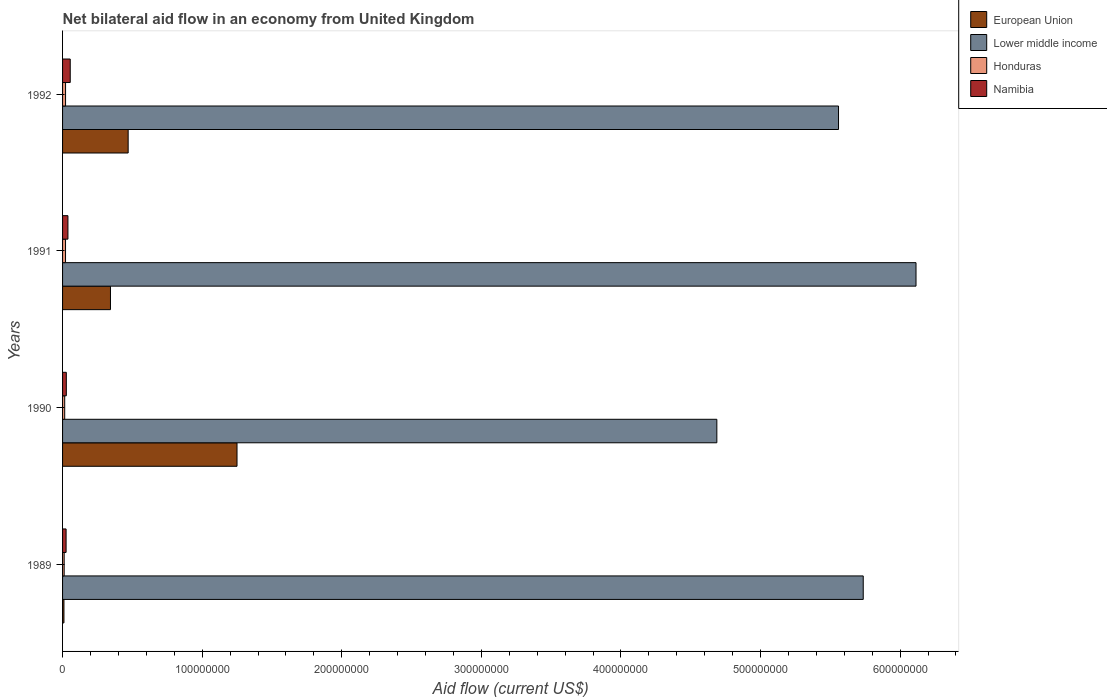How many different coloured bars are there?
Provide a succinct answer. 4. Are the number of bars per tick equal to the number of legend labels?
Ensure brevity in your answer.  Yes. How many bars are there on the 3rd tick from the top?
Ensure brevity in your answer.  4. How many bars are there on the 2nd tick from the bottom?
Provide a short and direct response. 4. What is the label of the 1st group of bars from the top?
Your answer should be compact. 1992. In how many cases, is the number of bars for a given year not equal to the number of legend labels?
Provide a short and direct response. 0. What is the net bilateral aid flow in European Union in 1991?
Your response must be concise. 3.43e+07. Across all years, what is the maximum net bilateral aid flow in Namibia?
Your response must be concise. 5.49e+06. Across all years, what is the minimum net bilateral aid flow in European Union?
Your response must be concise. 9.90e+05. What is the total net bilateral aid flow in Lower middle income in the graph?
Your answer should be compact. 2.21e+09. What is the difference between the net bilateral aid flow in Honduras in 1990 and that in 1991?
Ensure brevity in your answer.  -5.90e+05. What is the difference between the net bilateral aid flow in Namibia in 1990 and the net bilateral aid flow in European Union in 1989?
Keep it short and to the point. 1.71e+06. What is the average net bilateral aid flow in Honduras per year?
Your answer should be compact. 1.74e+06. In the year 1991, what is the difference between the net bilateral aid flow in Namibia and net bilateral aid flow in Honduras?
Offer a very short reply. 1.73e+06. What is the ratio of the net bilateral aid flow in Namibia in 1990 to that in 1992?
Your answer should be very brief. 0.49. Is the net bilateral aid flow in Honduras in 1990 less than that in 1992?
Provide a short and direct response. Yes. What is the difference between the highest and the second highest net bilateral aid flow in Namibia?
Keep it short and to the point. 1.64e+06. What is the difference between the highest and the lowest net bilateral aid flow in European Union?
Give a very brief answer. 1.24e+08. In how many years, is the net bilateral aid flow in Honduras greater than the average net bilateral aid flow in Honduras taken over all years?
Make the answer very short. 2. Is it the case that in every year, the sum of the net bilateral aid flow in European Union and net bilateral aid flow in Honduras is greater than the sum of net bilateral aid flow in Namibia and net bilateral aid flow in Lower middle income?
Your answer should be very brief. No. What does the 4th bar from the bottom in 1990 represents?
Your answer should be compact. Namibia. Are all the bars in the graph horizontal?
Keep it short and to the point. Yes. What is the difference between two consecutive major ticks on the X-axis?
Your response must be concise. 1.00e+08. Are the values on the major ticks of X-axis written in scientific E-notation?
Offer a very short reply. No. Does the graph contain any zero values?
Give a very brief answer. No. Does the graph contain grids?
Provide a succinct answer. No. Where does the legend appear in the graph?
Your answer should be compact. Top right. How many legend labels are there?
Provide a succinct answer. 4. What is the title of the graph?
Offer a terse response. Net bilateral aid flow in an economy from United Kingdom. What is the label or title of the X-axis?
Give a very brief answer. Aid flow (current US$). What is the label or title of the Y-axis?
Offer a terse response. Years. What is the Aid flow (current US$) in European Union in 1989?
Offer a very short reply. 9.90e+05. What is the Aid flow (current US$) of Lower middle income in 1989?
Your answer should be compact. 5.74e+08. What is the Aid flow (current US$) in Honduras in 1989?
Your answer should be very brief. 1.15e+06. What is the Aid flow (current US$) of Namibia in 1989?
Provide a short and direct response. 2.53e+06. What is the Aid flow (current US$) in European Union in 1990?
Your response must be concise. 1.25e+08. What is the Aid flow (current US$) in Lower middle income in 1990?
Ensure brevity in your answer.  4.69e+08. What is the Aid flow (current US$) of Honduras in 1990?
Give a very brief answer. 1.53e+06. What is the Aid flow (current US$) in Namibia in 1990?
Give a very brief answer. 2.70e+06. What is the Aid flow (current US$) of European Union in 1991?
Ensure brevity in your answer.  3.43e+07. What is the Aid flow (current US$) of Lower middle income in 1991?
Your answer should be compact. 6.11e+08. What is the Aid flow (current US$) in Honduras in 1991?
Ensure brevity in your answer.  2.12e+06. What is the Aid flow (current US$) in Namibia in 1991?
Ensure brevity in your answer.  3.85e+06. What is the Aid flow (current US$) of European Union in 1992?
Provide a short and direct response. 4.70e+07. What is the Aid flow (current US$) of Lower middle income in 1992?
Give a very brief answer. 5.56e+08. What is the Aid flow (current US$) of Honduras in 1992?
Your answer should be very brief. 2.15e+06. What is the Aid flow (current US$) of Namibia in 1992?
Offer a very short reply. 5.49e+06. Across all years, what is the maximum Aid flow (current US$) in European Union?
Offer a very short reply. 1.25e+08. Across all years, what is the maximum Aid flow (current US$) of Lower middle income?
Provide a short and direct response. 6.11e+08. Across all years, what is the maximum Aid flow (current US$) in Honduras?
Give a very brief answer. 2.15e+06. Across all years, what is the maximum Aid flow (current US$) of Namibia?
Offer a terse response. 5.49e+06. Across all years, what is the minimum Aid flow (current US$) of European Union?
Ensure brevity in your answer.  9.90e+05. Across all years, what is the minimum Aid flow (current US$) of Lower middle income?
Provide a short and direct response. 4.69e+08. Across all years, what is the minimum Aid flow (current US$) of Honduras?
Keep it short and to the point. 1.15e+06. Across all years, what is the minimum Aid flow (current US$) in Namibia?
Provide a succinct answer. 2.53e+06. What is the total Aid flow (current US$) in European Union in the graph?
Your response must be concise. 2.07e+08. What is the total Aid flow (current US$) in Lower middle income in the graph?
Your answer should be compact. 2.21e+09. What is the total Aid flow (current US$) in Honduras in the graph?
Provide a succinct answer. 6.95e+06. What is the total Aid flow (current US$) in Namibia in the graph?
Your answer should be compact. 1.46e+07. What is the difference between the Aid flow (current US$) of European Union in 1989 and that in 1990?
Keep it short and to the point. -1.24e+08. What is the difference between the Aid flow (current US$) of Lower middle income in 1989 and that in 1990?
Your answer should be very brief. 1.05e+08. What is the difference between the Aid flow (current US$) of Honduras in 1989 and that in 1990?
Give a very brief answer. -3.80e+05. What is the difference between the Aid flow (current US$) of Namibia in 1989 and that in 1990?
Keep it short and to the point. -1.70e+05. What is the difference between the Aid flow (current US$) of European Union in 1989 and that in 1991?
Provide a succinct answer. -3.33e+07. What is the difference between the Aid flow (current US$) in Lower middle income in 1989 and that in 1991?
Ensure brevity in your answer.  -3.78e+07. What is the difference between the Aid flow (current US$) of Honduras in 1989 and that in 1991?
Your answer should be very brief. -9.70e+05. What is the difference between the Aid flow (current US$) in Namibia in 1989 and that in 1991?
Provide a short and direct response. -1.32e+06. What is the difference between the Aid flow (current US$) of European Union in 1989 and that in 1992?
Give a very brief answer. -4.60e+07. What is the difference between the Aid flow (current US$) in Lower middle income in 1989 and that in 1992?
Your answer should be very brief. 1.77e+07. What is the difference between the Aid flow (current US$) in Honduras in 1989 and that in 1992?
Your answer should be very brief. -1.00e+06. What is the difference between the Aid flow (current US$) of Namibia in 1989 and that in 1992?
Give a very brief answer. -2.96e+06. What is the difference between the Aid flow (current US$) of European Union in 1990 and that in 1991?
Your answer should be compact. 9.06e+07. What is the difference between the Aid flow (current US$) in Lower middle income in 1990 and that in 1991?
Provide a succinct answer. -1.43e+08. What is the difference between the Aid flow (current US$) of Honduras in 1990 and that in 1991?
Ensure brevity in your answer.  -5.90e+05. What is the difference between the Aid flow (current US$) in Namibia in 1990 and that in 1991?
Keep it short and to the point. -1.15e+06. What is the difference between the Aid flow (current US$) of European Union in 1990 and that in 1992?
Ensure brevity in your answer.  7.80e+07. What is the difference between the Aid flow (current US$) of Lower middle income in 1990 and that in 1992?
Provide a succinct answer. -8.72e+07. What is the difference between the Aid flow (current US$) in Honduras in 1990 and that in 1992?
Your response must be concise. -6.20e+05. What is the difference between the Aid flow (current US$) in Namibia in 1990 and that in 1992?
Your answer should be very brief. -2.79e+06. What is the difference between the Aid flow (current US$) of European Union in 1991 and that in 1992?
Provide a short and direct response. -1.27e+07. What is the difference between the Aid flow (current US$) in Lower middle income in 1991 and that in 1992?
Offer a terse response. 5.55e+07. What is the difference between the Aid flow (current US$) of Honduras in 1991 and that in 1992?
Keep it short and to the point. -3.00e+04. What is the difference between the Aid flow (current US$) of Namibia in 1991 and that in 1992?
Offer a very short reply. -1.64e+06. What is the difference between the Aid flow (current US$) of European Union in 1989 and the Aid flow (current US$) of Lower middle income in 1990?
Your answer should be very brief. -4.68e+08. What is the difference between the Aid flow (current US$) in European Union in 1989 and the Aid flow (current US$) in Honduras in 1990?
Offer a terse response. -5.40e+05. What is the difference between the Aid flow (current US$) of European Union in 1989 and the Aid flow (current US$) of Namibia in 1990?
Your response must be concise. -1.71e+06. What is the difference between the Aid flow (current US$) in Lower middle income in 1989 and the Aid flow (current US$) in Honduras in 1990?
Provide a succinct answer. 5.72e+08. What is the difference between the Aid flow (current US$) in Lower middle income in 1989 and the Aid flow (current US$) in Namibia in 1990?
Make the answer very short. 5.71e+08. What is the difference between the Aid flow (current US$) in Honduras in 1989 and the Aid flow (current US$) in Namibia in 1990?
Your response must be concise. -1.55e+06. What is the difference between the Aid flow (current US$) in European Union in 1989 and the Aid flow (current US$) in Lower middle income in 1991?
Provide a succinct answer. -6.10e+08. What is the difference between the Aid flow (current US$) of European Union in 1989 and the Aid flow (current US$) of Honduras in 1991?
Keep it short and to the point. -1.13e+06. What is the difference between the Aid flow (current US$) of European Union in 1989 and the Aid flow (current US$) of Namibia in 1991?
Your answer should be compact. -2.86e+06. What is the difference between the Aid flow (current US$) of Lower middle income in 1989 and the Aid flow (current US$) of Honduras in 1991?
Give a very brief answer. 5.71e+08. What is the difference between the Aid flow (current US$) of Lower middle income in 1989 and the Aid flow (current US$) of Namibia in 1991?
Provide a succinct answer. 5.70e+08. What is the difference between the Aid flow (current US$) in Honduras in 1989 and the Aid flow (current US$) in Namibia in 1991?
Provide a short and direct response. -2.70e+06. What is the difference between the Aid flow (current US$) of European Union in 1989 and the Aid flow (current US$) of Lower middle income in 1992?
Keep it short and to the point. -5.55e+08. What is the difference between the Aid flow (current US$) of European Union in 1989 and the Aid flow (current US$) of Honduras in 1992?
Your answer should be compact. -1.16e+06. What is the difference between the Aid flow (current US$) in European Union in 1989 and the Aid flow (current US$) in Namibia in 1992?
Provide a short and direct response. -4.50e+06. What is the difference between the Aid flow (current US$) of Lower middle income in 1989 and the Aid flow (current US$) of Honduras in 1992?
Give a very brief answer. 5.71e+08. What is the difference between the Aid flow (current US$) of Lower middle income in 1989 and the Aid flow (current US$) of Namibia in 1992?
Keep it short and to the point. 5.68e+08. What is the difference between the Aid flow (current US$) in Honduras in 1989 and the Aid flow (current US$) in Namibia in 1992?
Ensure brevity in your answer.  -4.34e+06. What is the difference between the Aid flow (current US$) of European Union in 1990 and the Aid flow (current US$) of Lower middle income in 1991?
Provide a short and direct response. -4.86e+08. What is the difference between the Aid flow (current US$) of European Union in 1990 and the Aid flow (current US$) of Honduras in 1991?
Provide a succinct answer. 1.23e+08. What is the difference between the Aid flow (current US$) of European Union in 1990 and the Aid flow (current US$) of Namibia in 1991?
Your answer should be very brief. 1.21e+08. What is the difference between the Aid flow (current US$) of Lower middle income in 1990 and the Aid flow (current US$) of Honduras in 1991?
Your answer should be very brief. 4.67e+08. What is the difference between the Aid flow (current US$) in Lower middle income in 1990 and the Aid flow (current US$) in Namibia in 1991?
Give a very brief answer. 4.65e+08. What is the difference between the Aid flow (current US$) of Honduras in 1990 and the Aid flow (current US$) of Namibia in 1991?
Your response must be concise. -2.32e+06. What is the difference between the Aid flow (current US$) of European Union in 1990 and the Aid flow (current US$) of Lower middle income in 1992?
Your response must be concise. -4.31e+08. What is the difference between the Aid flow (current US$) in European Union in 1990 and the Aid flow (current US$) in Honduras in 1992?
Your answer should be compact. 1.23e+08. What is the difference between the Aid flow (current US$) of European Union in 1990 and the Aid flow (current US$) of Namibia in 1992?
Provide a succinct answer. 1.19e+08. What is the difference between the Aid flow (current US$) in Lower middle income in 1990 and the Aid flow (current US$) in Honduras in 1992?
Offer a very short reply. 4.67e+08. What is the difference between the Aid flow (current US$) of Lower middle income in 1990 and the Aid flow (current US$) of Namibia in 1992?
Provide a succinct answer. 4.63e+08. What is the difference between the Aid flow (current US$) of Honduras in 1990 and the Aid flow (current US$) of Namibia in 1992?
Offer a very short reply. -3.96e+06. What is the difference between the Aid flow (current US$) in European Union in 1991 and the Aid flow (current US$) in Lower middle income in 1992?
Your answer should be compact. -5.22e+08. What is the difference between the Aid flow (current US$) in European Union in 1991 and the Aid flow (current US$) in Honduras in 1992?
Provide a succinct answer. 3.22e+07. What is the difference between the Aid flow (current US$) in European Union in 1991 and the Aid flow (current US$) in Namibia in 1992?
Provide a succinct answer. 2.88e+07. What is the difference between the Aid flow (current US$) of Lower middle income in 1991 and the Aid flow (current US$) of Honduras in 1992?
Give a very brief answer. 6.09e+08. What is the difference between the Aid flow (current US$) of Lower middle income in 1991 and the Aid flow (current US$) of Namibia in 1992?
Make the answer very short. 6.06e+08. What is the difference between the Aid flow (current US$) of Honduras in 1991 and the Aid flow (current US$) of Namibia in 1992?
Your answer should be compact. -3.37e+06. What is the average Aid flow (current US$) of European Union per year?
Offer a terse response. 5.18e+07. What is the average Aid flow (current US$) of Lower middle income per year?
Your response must be concise. 5.52e+08. What is the average Aid flow (current US$) in Honduras per year?
Make the answer very short. 1.74e+06. What is the average Aid flow (current US$) in Namibia per year?
Your response must be concise. 3.64e+06. In the year 1989, what is the difference between the Aid flow (current US$) of European Union and Aid flow (current US$) of Lower middle income?
Make the answer very short. -5.73e+08. In the year 1989, what is the difference between the Aid flow (current US$) in European Union and Aid flow (current US$) in Namibia?
Offer a terse response. -1.54e+06. In the year 1989, what is the difference between the Aid flow (current US$) of Lower middle income and Aid flow (current US$) of Honduras?
Keep it short and to the point. 5.72e+08. In the year 1989, what is the difference between the Aid flow (current US$) of Lower middle income and Aid flow (current US$) of Namibia?
Offer a very short reply. 5.71e+08. In the year 1989, what is the difference between the Aid flow (current US$) in Honduras and Aid flow (current US$) in Namibia?
Make the answer very short. -1.38e+06. In the year 1990, what is the difference between the Aid flow (current US$) in European Union and Aid flow (current US$) in Lower middle income?
Offer a terse response. -3.44e+08. In the year 1990, what is the difference between the Aid flow (current US$) of European Union and Aid flow (current US$) of Honduras?
Offer a very short reply. 1.23e+08. In the year 1990, what is the difference between the Aid flow (current US$) in European Union and Aid flow (current US$) in Namibia?
Offer a terse response. 1.22e+08. In the year 1990, what is the difference between the Aid flow (current US$) of Lower middle income and Aid flow (current US$) of Honduras?
Offer a very short reply. 4.67e+08. In the year 1990, what is the difference between the Aid flow (current US$) in Lower middle income and Aid flow (current US$) in Namibia?
Ensure brevity in your answer.  4.66e+08. In the year 1990, what is the difference between the Aid flow (current US$) of Honduras and Aid flow (current US$) of Namibia?
Make the answer very short. -1.17e+06. In the year 1991, what is the difference between the Aid flow (current US$) in European Union and Aid flow (current US$) in Lower middle income?
Make the answer very short. -5.77e+08. In the year 1991, what is the difference between the Aid flow (current US$) in European Union and Aid flow (current US$) in Honduras?
Keep it short and to the point. 3.22e+07. In the year 1991, what is the difference between the Aid flow (current US$) in European Union and Aid flow (current US$) in Namibia?
Keep it short and to the point. 3.05e+07. In the year 1991, what is the difference between the Aid flow (current US$) of Lower middle income and Aid flow (current US$) of Honduras?
Offer a very short reply. 6.09e+08. In the year 1991, what is the difference between the Aid flow (current US$) in Lower middle income and Aid flow (current US$) in Namibia?
Ensure brevity in your answer.  6.08e+08. In the year 1991, what is the difference between the Aid flow (current US$) in Honduras and Aid flow (current US$) in Namibia?
Provide a short and direct response. -1.73e+06. In the year 1992, what is the difference between the Aid flow (current US$) of European Union and Aid flow (current US$) of Lower middle income?
Your answer should be compact. -5.09e+08. In the year 1992, what is the difference between the Aid flow (current US$) of European Union and Aid flow (current US$) of Honduras?
Keep it short and to the point. 4.48e+07. In the year 1992, what is the difference between the Aid flow (current US$) of European Union and Aid flow (current US$) of Namibia?
Give a very brief answer. 4.15e+07. In the year 1992, what is the difference between the Aid flow (current US$) in Lower middle income and Aid flow (current US$) in Honduras?
Your answer should be compact. 5.54e+08. In the year 1992, what is the difference between the Aid flow (current US$) in Lower middle income and Aid flow (current US$) in Namibia?
Offer a terse response. 5.50e+08. In the year 1992, what is the difference between the Aid flow (current US$) in Honduras and Aid flow (current US$) in Namibia?
Ensure brevity in your answer.  -3.34e+06. What is the ratio of the Aid flow (current US$) of European Union in 1989 to that in 1990?
Offer a terse response. 0.01. What is the ratio of the Aid flow (current US$) in Lower middle income in 1989 to that in 1990?
Your answer should be very brief. 1.22. What is the ratio of the Aid flow (current US$) in Honduras in 1989 to that in 1990?
Offer a very short reply. 0.75. What is the ratio of the Aid flow (current US$) in Namibia in 1989 to that in 1990?
Keep it short and to the point. 0.94. What is the ratio of the Aid flow (current US$) of European Union in 1989 to that in 1991?
Your answer should be compact. 0.03. What is the ratio of the Aid flow (current US$) of Lower middle income in 1989 to that in 1991?
Your answer should be compact. 0.94. What is the ratio of the Aid flow (current US$) of Honduras in 1989 to that in 1991?
Provide a short and direct response. 0.54. What is the ratio of the Aid flow (current US$) in Namibia in 1989 to that in 1991?
Provide a succinct answer. 0.66. What is the ratio of the Aid flow (current US$) in European Union in 1989 to that in 1992?
Ensure brevity in your answer.  0.02. What is the ratio of the Aid flow (current US$) in Lower middle income in 1989 to that in 1992?
Offer a very short reply. 1.03. What is the ratio of the Aid flow (current US$) of Honduras in 1989 to that in 1992?
Your answer should be compact. 0.53. What is the ratio of the Aid flow (current US$) of Namibia in 1989 to that in 1992?
Your answer should be compact. 0.46. What is the ratio of the Aid flow (current US$) in European Union in 1990 to that in 1991?
Make the answer very short. 3.64. What is the ratio of the Aid flow (current US$) in Lower middle income in 1990 to that in 1991?
Your answer should be compact. 0.77. What is the ratio of the Aid flow (current US$) in Honduras in 1990 to that in 1991?
Keep it short and to the point. 0.72. What is the ratio of the Aid flow (current US$) of Namibia in 1990 to that in 1991?
Provide a succinct answer. 0.7. What is the ratio of the Aid flow (current US$) in European Union in 1990 to that in 1992?
Provide a succinct answer. 2.66. What is the ratio of the Aid flow (current US$) of Lower middle income in 1990 to that in 1992?
Your response must be concise. 0.84. What is the ratio of the Aid flow (current US$) of Honduras in 1990 to that in 1992?
Provide a succinct answer. 0.71. What is the ratio of the Aid flow (current US$) of Namibia in 1990 to that in 1992?
Your answer should be very brief. 0.49. What is the ratio of the Aid flow (current US$) of European Union in 1991 to that in 1992?
Ensure brevity in your answer.  0.73. What is the ratio of the Aid flow (current US$) in Lower middle income in 1991 to that in 1992?
Your answer should be very brief. 1.1. What is the ratio of the Aid flow (current US$) of Honduras in 1991 to that in 1992?
Keep it short and to the point. 0.99. What is the ratio of the Aid flow (current US$) of Namibia in 1991 to that in 1992?
Your answer should be very brief. 0.7. What is the difference between the highest and the second highest Aid flow (current US$) in European Union?
Your answer should be compact. 7.80e+07. What is the difference between the highest and the second highest Aid flow (current US$) in Lower middle income?
Offer a very short reply. 3.78e+07. What is the difference between the highest and the second highest Aid flow (current US$) in Honduras?
Make the answer very short. 3.00e+04. What is the difference between the highest and the second highest Aid flow (current US$) in Namibia?
Offer a very short reply. 1.64e+06. What is the difference between the highest and the lowest Aid flow (current US$) in European Union?
Your response must be concise. 1.24e+08. What is the difference between the highest and the lowest Aid flow (current US$) in Lower middle income?
Provide a short and direct response. 1.43e+08. What is the difference between the highest and the lowest Aid flow (current US$) in Honduras?
Give a very brief answer. 1.00e+06. What is the difference between the highest and the lowest Aid flow (current US$) in Namibia?
Keep it short and to the point. 2.96e+06. 